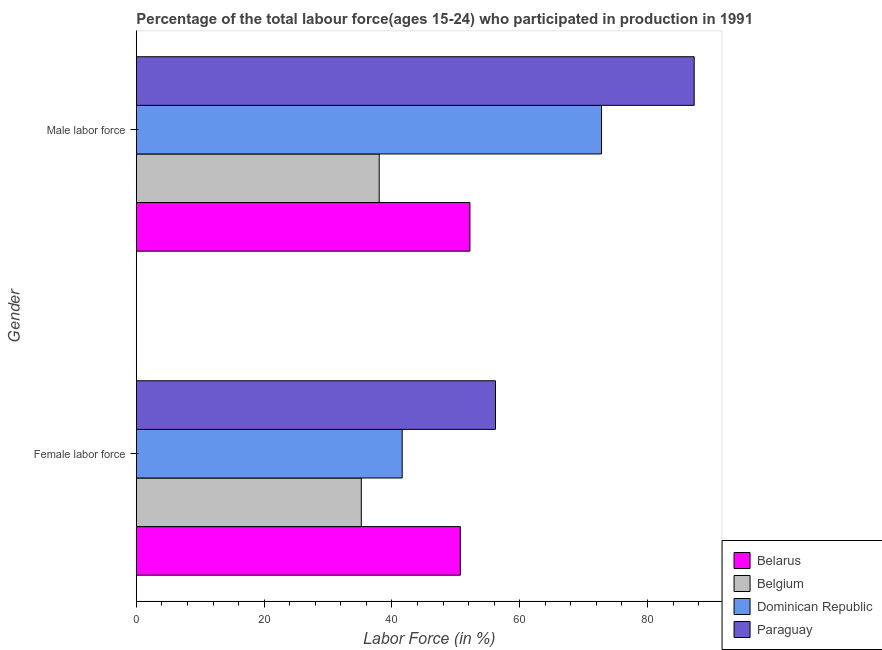How many different coloured bars are there?
Your answer should be very brief. 4. Are the number of bars on each tick of the Y-axis equal?
Your response must be concise. Yes. How many bars are there on the 2nd tick from the top?
Make the answer very short. 4. How many bars are there on the 2nd tick from the bottom?
Offer a terse response. 4. What is the label of the 1st group of bars from the top?
Provide a short and direct response. Male labor force. Across all countries, what is the maximum percentage of female labor force?
Give a very brief answer. 56.2. In which country was the percentage of female labor force maximum?
Provide a short and direct response. Paraguay. What is the total percentage of male labour force in the graph?
Ensure brevity in your answer.  250.3. What is the difference between the percentage of female labor force in Paraguay and that in Dominican Republic?
Your answer should be very brief. 14.6. What is the average percentage of male labour force per country?
Keep it short and to the point. 62.58. What is the difference between the percentage of female labor force and percentage of male labour force in Belarus?
Your answer should be compact. -1.5. What is the ratio of the percentage of female labor force in Dominican Republic to that in Paraguay?
Provide a short and direct response. 0.74. In how many countries, is the percentage of male labour force greater than the average percentage of male labour force taken over all countries?
Provide a succinct answer. 2. What does the 1st bar from the top in Female labor force represents?
Give a very brief answer. Paraguay. What does the 3rd bar from the bottom in Male labor force represents?
Your answer should be very brief. Dominican Republic. Are all the bars in the graph horizontal?
Your answer should be very brief. Yes. How many countries are there in the graph?
Ensure brevity in your answer.  4. What is the difference between two consecutive major ticks on the X-axis?
Provide a short and direct response. 20. Are the values on the major ticks of X-axis written in scientific E-notation?
Provide a succinct answer. No. Where does the legend appear in the graph?
Provide a short and direct response. Bottom right. How are the legend labels stacked?
Provide a short and direct response. Vertical. What is the title of the graph?
Give a very brief answer. Percentage of the total labour force(ages 15-24) who participated in production in 1991. Does "Congo (Democratic)" appear as one of the legend labels in the graph?
Your answer should be compact. No. What is the label or title of the X-axis?
Your answer should be compact. Labor Force (in %). What is the Labor Force (in %) of Belarus in Female labor force?
Offer a terse response. 50.7. What is the Labor Force (in %) of Belgium in Female labor force?
Your answer should be compact. 35.2. What is the Labor Force (in %) of Dominican Republic in Female labor force?
Your answer should be very brief. 41.6. What is the Labor Force (in %) in Paraguay in Female labor force?
Offer a terse response. 56.2. What is the Labor Force (in %) of Belarus in Male labor force?
Offer a terse response. 52.2. What is the Labor Force (in %) in Dominican Republic in Male labor force?
Offer a very short reply. 72.8. What is the Labor Force (in %) in Paraguay in Male labor force?
Your answer should be compact. 87.3. Across all Gender, what is the maximum Labor Force (in %) of Belarus?
Your response must be concise. 52.2. Across all Gender, what is the maximum Labor Force (in %) in Belgium?
Offer a terse response. 38. Across all Gender, what is the maximum Labor Force (in %) in Dominican Republic?
Ensure brevity in your answer.  72.8. Across all Gender, what is the maximum Labor Force (in %) in Paraguay?
Offer a very short reply. 87.3. Across all Gender, what is the minimum Labor Force (in %) of Belarus?
Give a very brief answer. 50.7. Across all Gender, what is the minimum Labor Force (in %) in Belgium?
Keep it short and to the point. 35.2. Across all Gender, what is the minimum Labor Force (in %) of Dominican Republic?
Offer a very short reply. 41.6. Across all Gender, what is the minimum Labor Force (in %) of Paraguay?
Offer a very short reply. 56.2. What is the total Labor Force (in %) in Belarus in the graph?
Offer a terse response. 102.9. What is the total Labor Force (in %) of Belgium in the graph?
Provide a short and direct response. 73.2. What is the total Labor Force (in %) of Dominican Republic in the graph?
Make the answer very short. 114.4. What is the total Labor Force (in %) in Paraguay in the graph?
Give a very brief answer. 143.5. What is the difference between the Labor Force (in %) in Dominican Republic in Female labor force and that in Male labor force?
Your answer should be compact. -31.2. What is the difference between the Labor Force (in %) in Paraguay in Female labor force and that in Male labor force?
Your answer should be compact. -31.1. What is the difference between the Labor Force (in %) in Belarus in Female labor force and the Labor Force (in %) in Dominican Republic in Male labor force?
Provide a succinct answer. -22.1. What is the difference between the Labor Force (in %) of Belarus in Female labor force and the Labor Force (in %) of Paraguay in Male labor force?
Make the answer very short. -36.6. What is the difference between the Labor Force (in %) of Belgium in Female labor force and the Labor Force (in %) of Dominican Republic in Male labor force?
Ensure brevity in your answer.  -37.6. What is the difference between the Labor Force (in %) of Belgium in Female labor force and the Labor Force (in %) of Paraguay in Male labor force?
Offer a terse response. -52.1. What is the difference between the Labor Force (in %) of Dominican Republic in Female labor force and the Labor Force (in %) of Paraguay in Male labor force?
Make the answer very short. -45.7. What is the average Labor Force (in %) of Belarus per Gender?
Ensure brevity in your answer.  51.45. What is the average Labor Force (in %) in Belgium per Gender?
Keep it short and to the point. 36.6. What is the average Labor Force (in %) of Dominican Republic per Gender?
Offer a terse response. 57.2. What is the average Labor Force (in %) of Paraguay per Gender?
Make the answer very short. 71.75. What is the difference between the Labor Force (in %) of Belarus and Labor Force (in %) of Dominican Republic in Female labor force?
Ensure brevity in your answer.  9.1. What is the difference between the Labor Force (in %) of Belarus and Labor Force (in %) of Paraguay in Female labor force?
Provide a short and direct response. -5.5. What is the difference between the Labor Force (in %) in Belgium and Labor Force (in %) in Dominican Republic in Female labor force?
Provide a short and direct response. -6.4. What is the difference between the Labor Force (in %) in Dominican Republic and Labor Force (in %) in Paraguay in Female labor force?
Your answer should be compact. -14.6. What is the difference between the Labor Force (in %) of Belarus and Labor Force (in %) of Dominican Republic in Male labor force?
Your answer should be very brief. -20.6. What is the difference between the Labor Force (in %) of Belarus and Labor Force (in %) of Paraguay in Male labor force?
Keep it short and to the point. -35.1. What is the difference between the Labor Force (in %) in Belgium and Labor Force (in %) in Dominican Republic in Male labor force?
Make the answer very short. -34.8. What is the difference between the Labor Force (in %) in Belgium and Labor Force (in %) in Paraguay in Male labor force?
Provide a succinct answer. -49.3. What is the ratio of the Labor Force (in %) of Belarus in Female labor force to that in Male labor force?
Your answer should be compact. 0.97. What is the ratio of the Labor Force (in %) in Belgium in Female labor force to that in Male labor force?
Offer a very short reply. 0.93. What is the ratio of the Labor Force (in %) in Paraguay in Female labor force to that in Male labor force?
Your response must be concise. 0.64. What is the difference between the highest and the second highest Labor Force (in %) of Belarus?
Your answer should be compact. 1.5. What is the difference between the highest and the second highest Labor Force (in %) of Dominican Republic?
Make the answer very short. 31.2. What is the difference between the highest and the second highest Labor Force (in %) in Paraguay?
Provide a succinct answer. 31.1. What is the difference between the highest and the lowest Labor Force (in %) of Belarus?
Offer a terse response. 1.5. What is the difference between the highest and the lowest Labor Force (in %) in Dominican Republic?
Give a very brief answer. 31.2. What is the difference between the highest and the lowest Labor Force (in %) in Paraguay?
Your response must be concise. 31.1. 